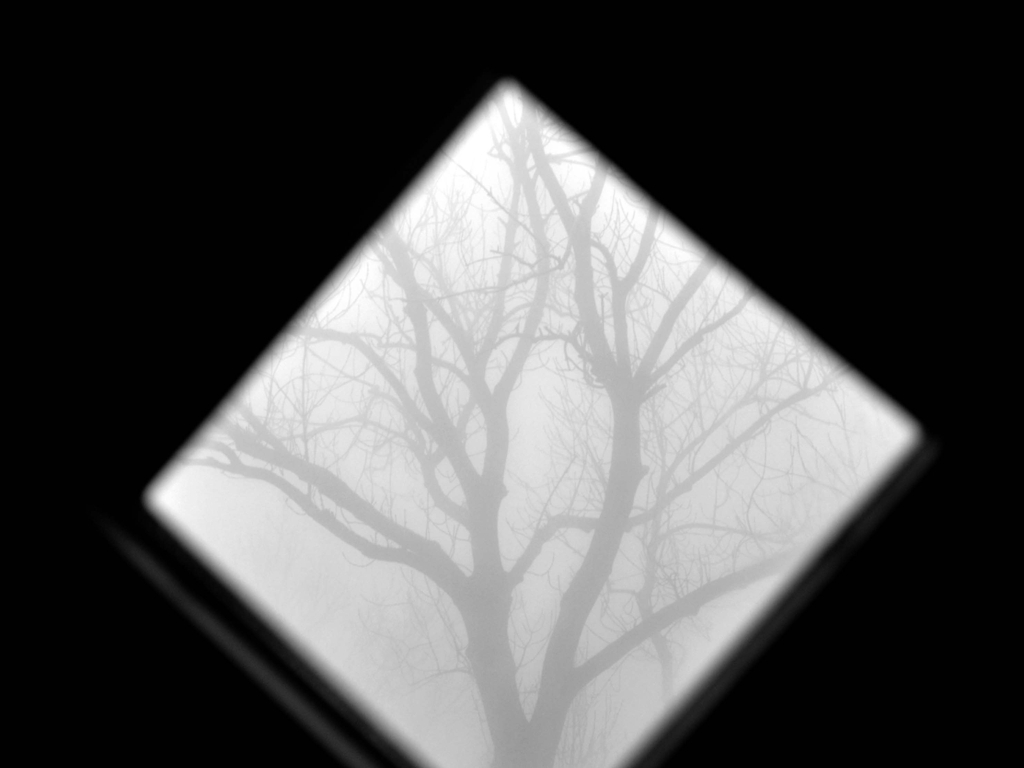What feeling does this image evoke, and could you elaborate on its possible symbolic meaning? The image, with its stark contrast of tree branches against a foggy background, evokes a sense of solitude and introspection. It may symbolize the complexity of thoughts, the mind's contemplation, or even the feeling of isolation one might experience in life's more challenging moments. The obscured background could represent uncertainty or the unknown future. 